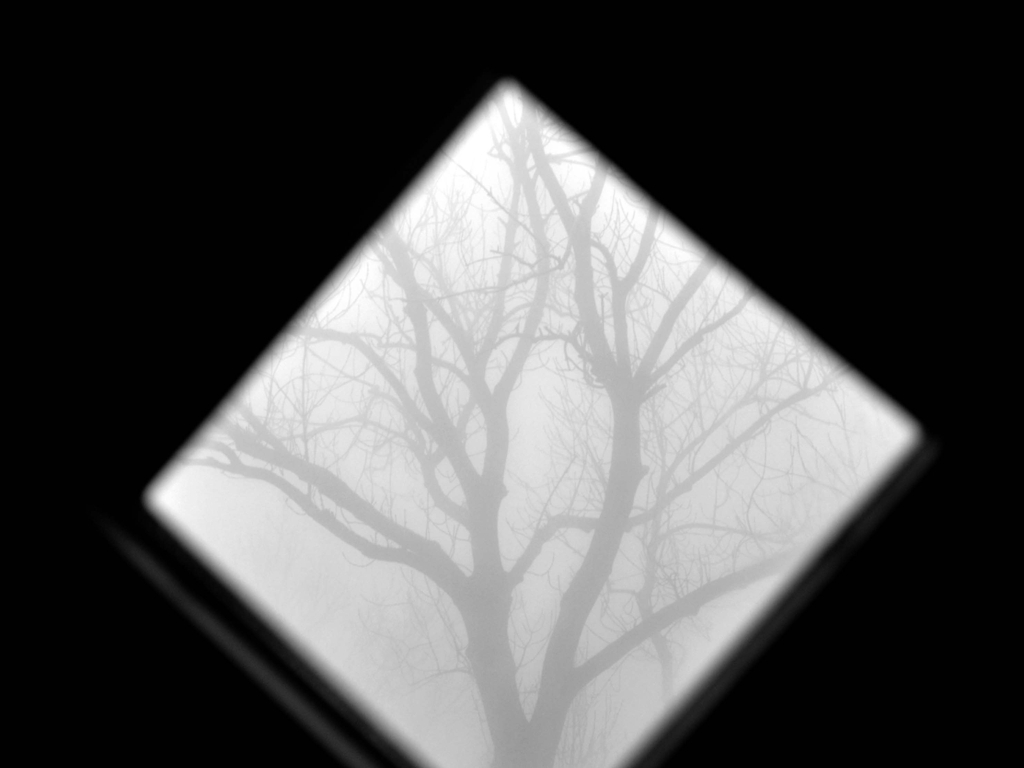What feeling does this image evoke, and could you elaborate on its possible symbolic meaning? The image, with its stark contrast of tree branches against a foggy background, evokes a sense of solitude and introspection. It may symbolize the complexity of thoughts, the mind's contemplation, or even the feeling of isolation one might experience in life's more challenging moments. The obscured background could represent uncertainty or the unknown future. 